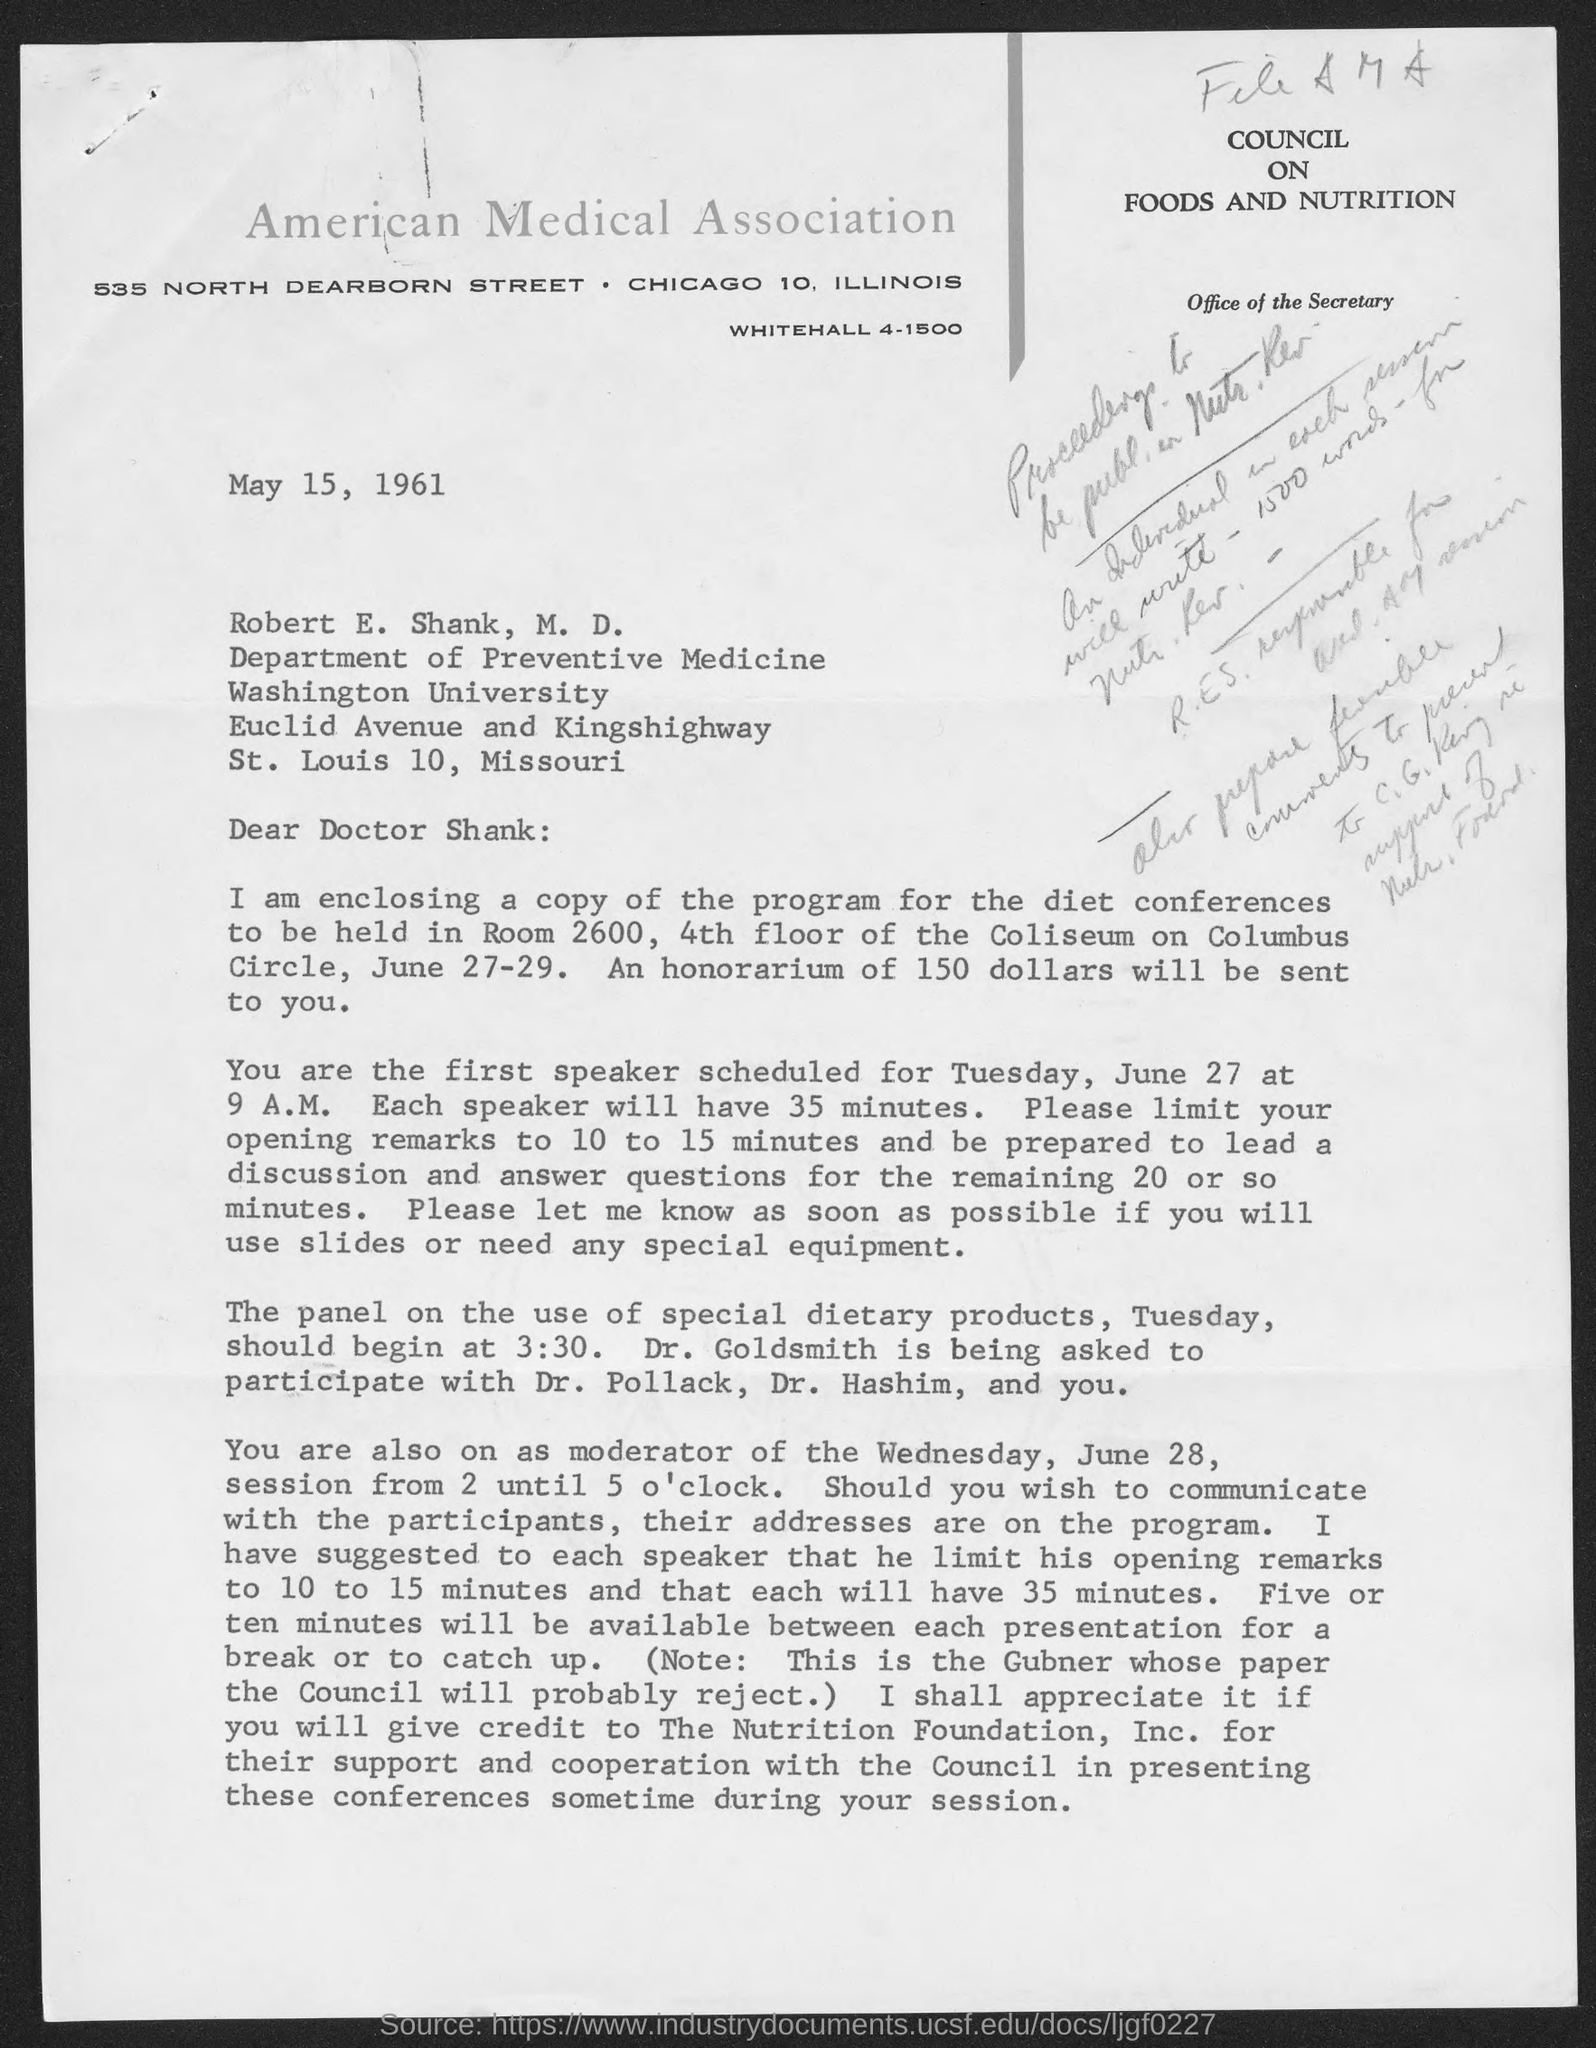Specify some key components in this picture. It is recommended that a speaker limit their opening remarks to a time frame of 10 to 15 minutes. The date on the document is May 15, 1961. The honorarium to be sent is 150 dollars. The duration of each speaker's presentation is scheduled to be 35 minutes. It is estimated that there will be five or ten minutes for a break. 